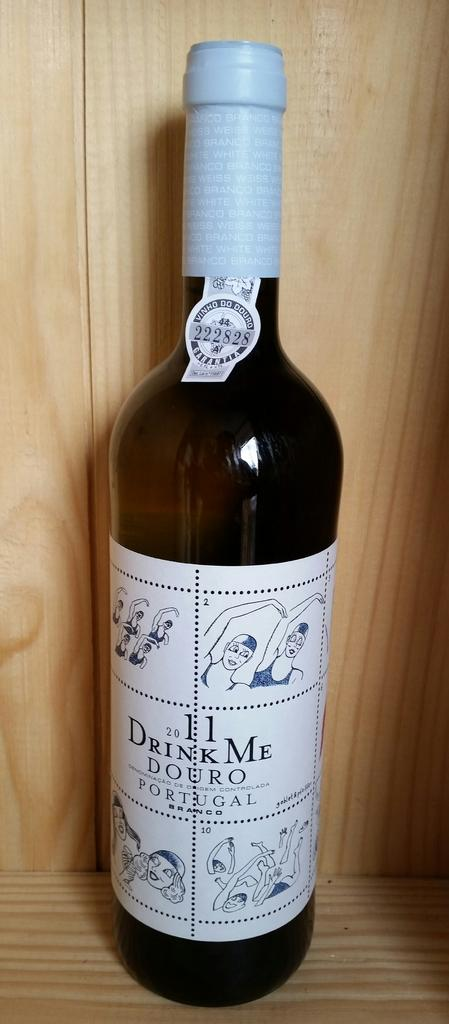<image>
Give a short and clear explanation of the subsequent image. A bottle of wine or liquor that says "Drink Me" on it. 